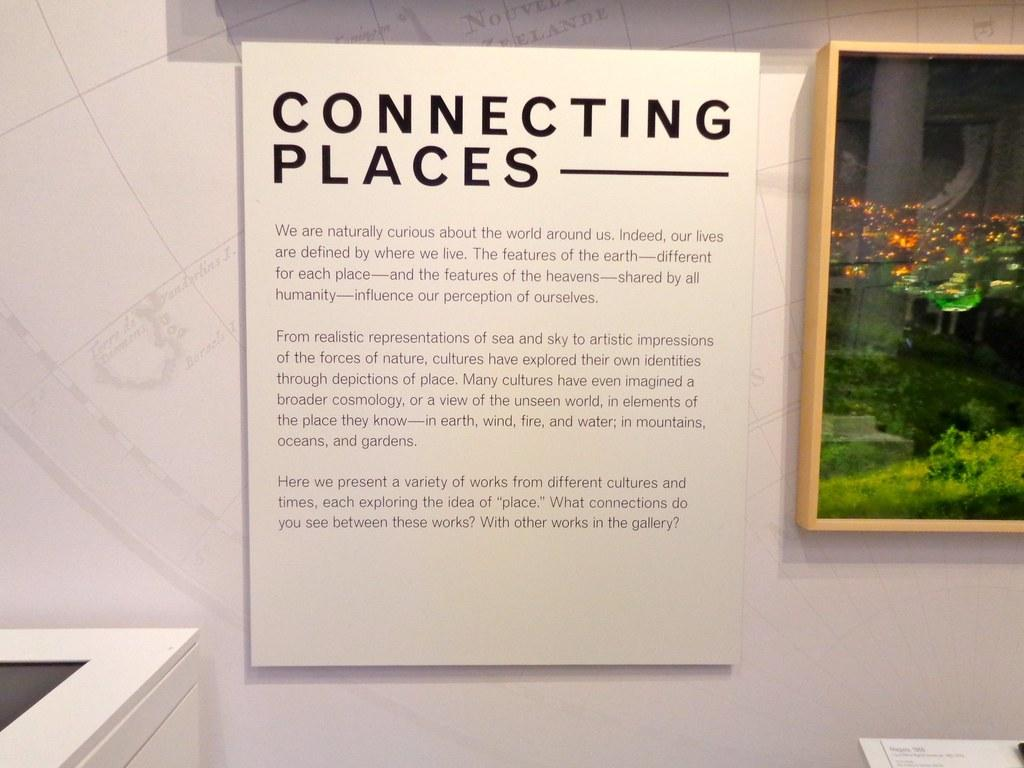What is the main object in the image? There is a photo frame in the image. What can be seen on the wall in the image? There is a poster with text on the wall. Can you describe any other objects in the image? There are other unspecified objects in the image. How many cakes are being offered in the image? There are no cakes present in the image. What type of waves can be seen in the image? There are no waves present in the image. 